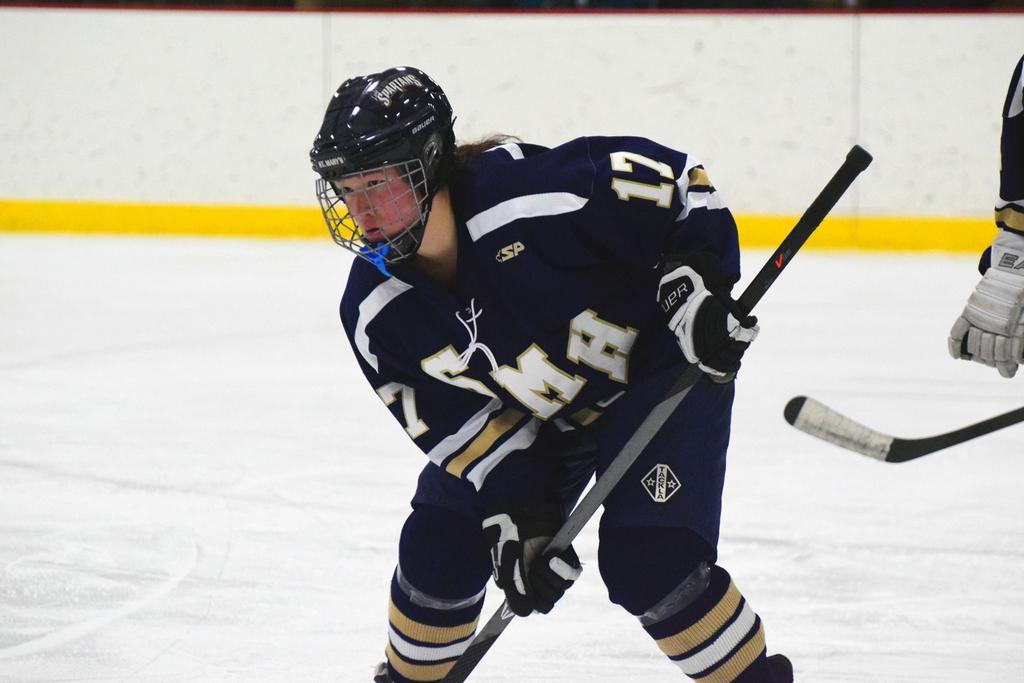Please provide a concise description of this image. In this picture we can see a man wore a helmet, gloves and holding a stick with his hand and in the background we can see a person. 